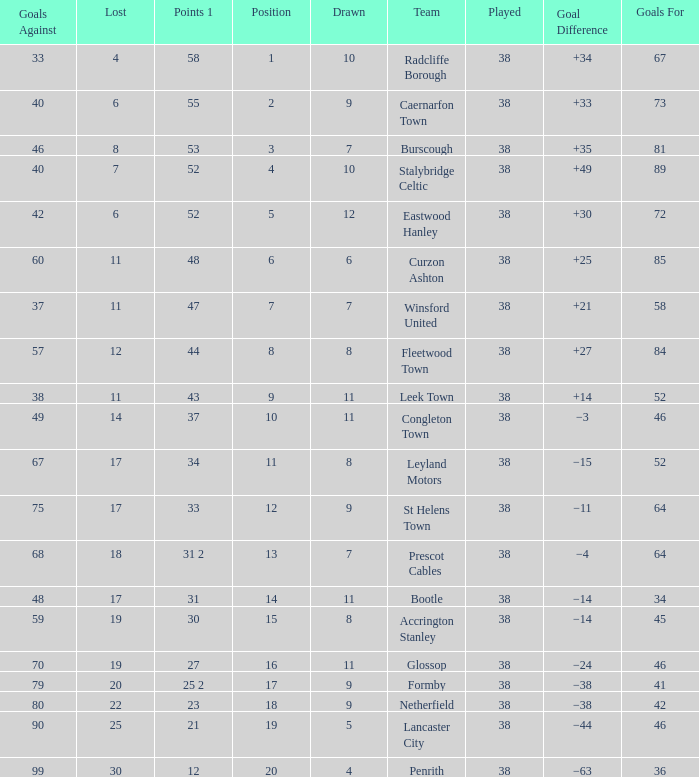WHAT IS THE SUM PLAYED WITH POINTS 1 OF 53, AND POSITION LARGER THAN 3? None. 